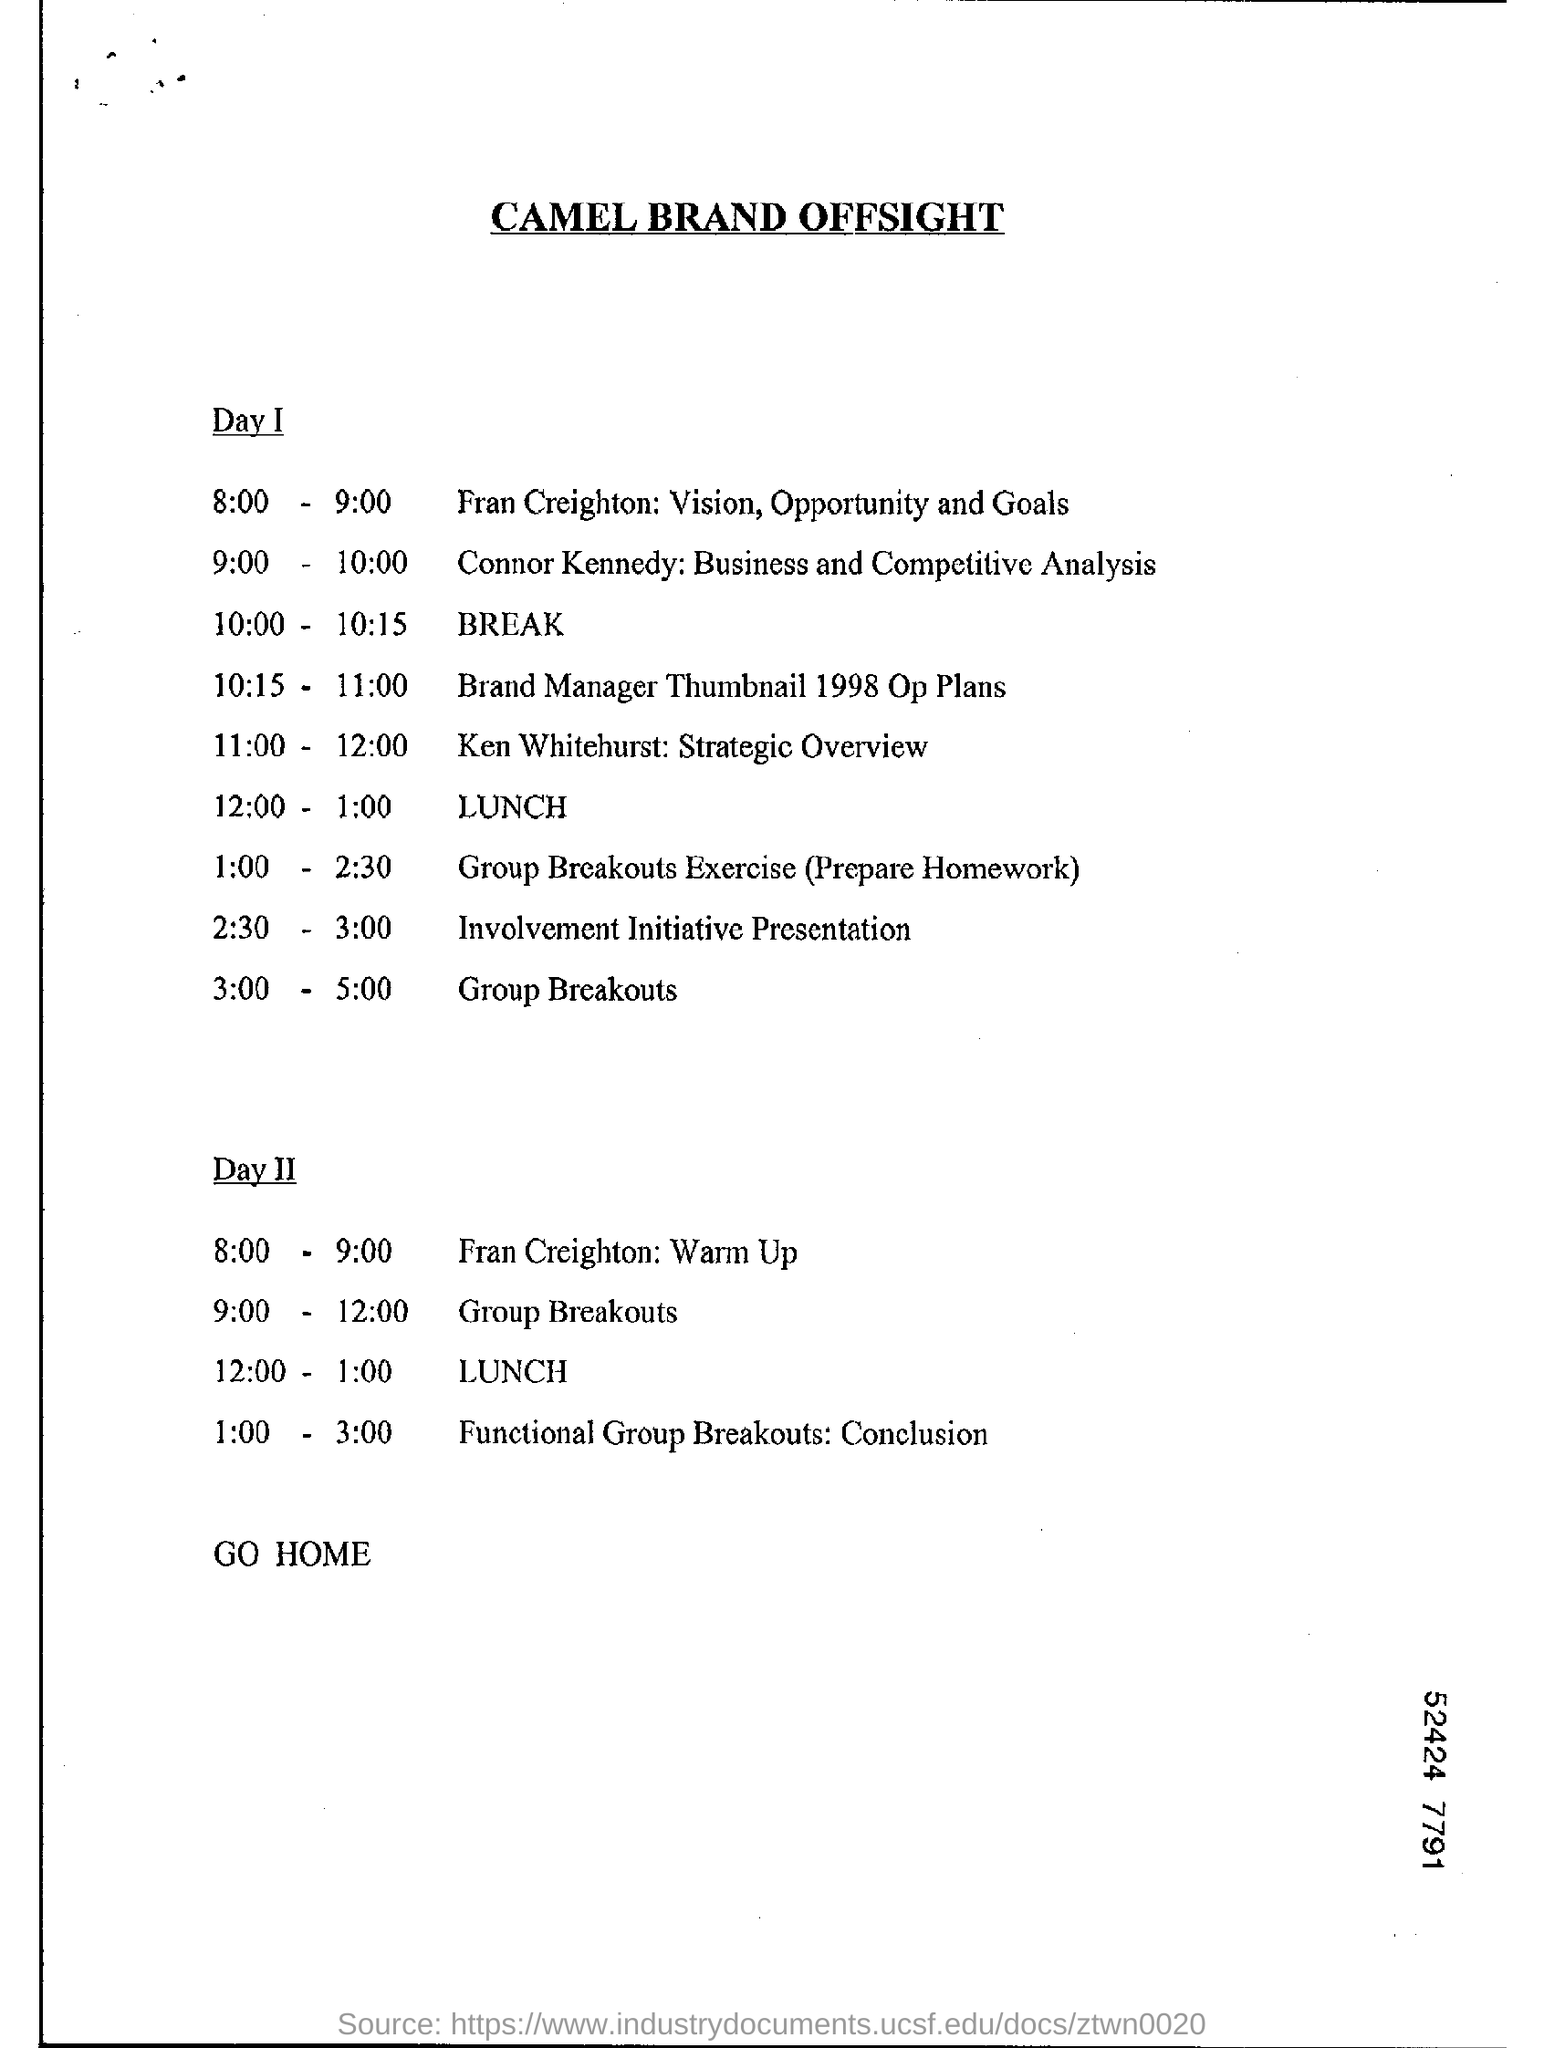What is the title of the document?
Make the answer very short. CAMEL BRAND OFFSIGHT. What is the program scheduled on Day II, 9:00  -  12:00 ?
Provide a succinct answer. Group Breakouts. On which day, Ken Whitehurst: Strategic Overview is scheduled?
Your response must be concise. Day I. 